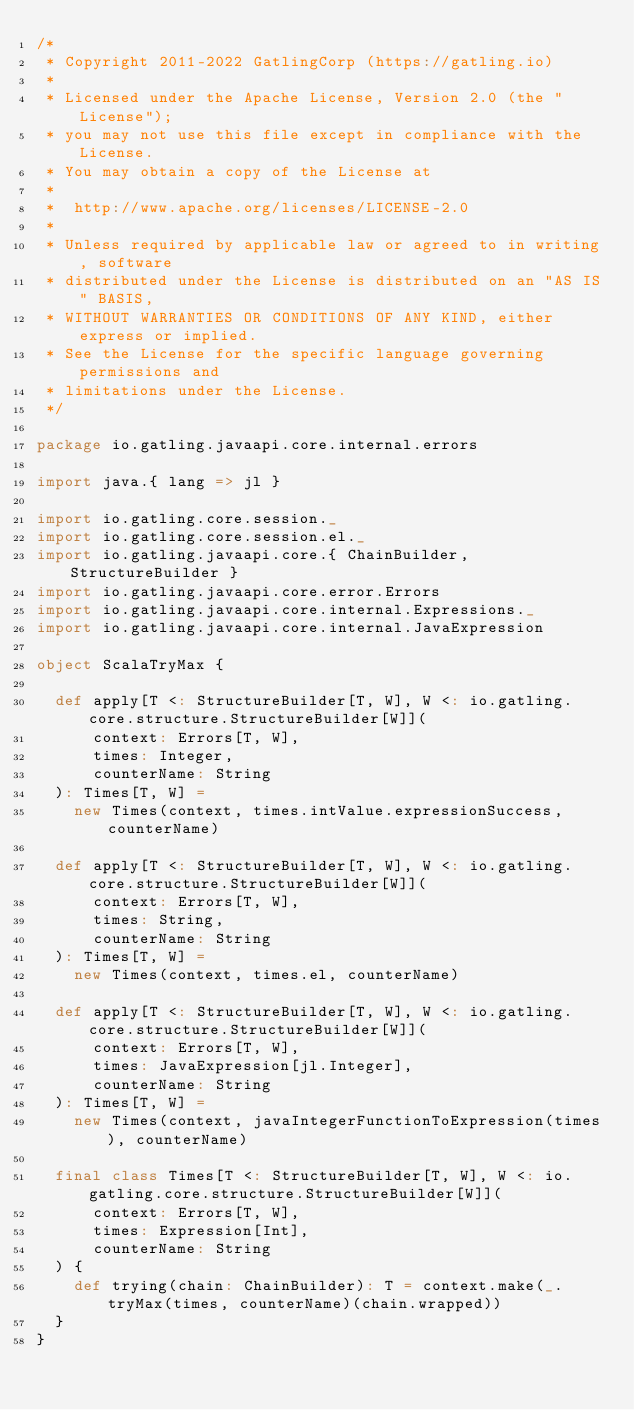<code> <loc_0><loc_0><loc_500><loc_500><_Scala_>/*
 * Copyright 2011-2022 GatlingCorp (https://gatling.io)
 *
 * Licensed under the Apache License, Version 2.0 (the "License");
 * you may not use this file except in compliance with the License.
 * You may obtain a copy of the License at
 *
 *  http://www.apache.org/licenses/LICENSE-2.0
 *
 * Unless required by applicable law or agreed to in writing, software
 * distributed under the License is distributed on an "AS IS" BASIS,
 * WITHOUT WARRANTIES OR CONDITIONS OF ANY KIND, either express or implied.
 * See the License for the specific language governing permissions and
 * limitations under the License.
 */

package io.gatling.javaapi.core.internal.errors

import java.{ lang => jl }

import io.gatling.core.session._
import io.gatling.core.session.el._
import io.gatling.javaapi.core.{ ChainBuilder, StructureBuilder }
import io.gatling.javaapi.core.error.Errors
import io.gatling.javaapi.core.internal.Expressions._
import io.gatling.javaapi.core.internal.JavaExpression

object ScalaTryMax {

  def apply[T <: StructureBuilder[T, W], W <: io.gatling.core.structure.StructureBuilder[W]](
      context: Errors[T, W],
      times: Integer,
      counterName: String
  ): Times[T, W] =
    new Times(context, times.intValue.expressionSuccess, counterName)

  def apply[T <: StructureBuilder[T, W], W <: io.gatling.core.structure.StructureBuilder[W]](
      context: Errors[T, W],
      times: String,
      counterName: String
  ): Times[T, W] =
    new Times(context, times.el, counterName)

  def apply[T <: StructureBuilder[T, W], W <: io.gatling.core.structure.StructureBuilder[W]](
      context: Errors[T, W],
      times: JavaExpression[jl.Integer],
      counterName: String
  ): Times[T, W] =
    new Times(context, javaIntegerFunctionToExpression(times), counterName)

  final class Times[T <: StructureBuilder[T, W], W <: io.gatling.core.structure.StructureBuilder[W]](
      context: Errors[T, W],
      times: Expression[Int],
      counterName: String
  ) {
    def trying(chain: ChainBuilder): T = context.make(_.tryMax(times, counterName)(chain.wrapped))
  }
}
</code> 